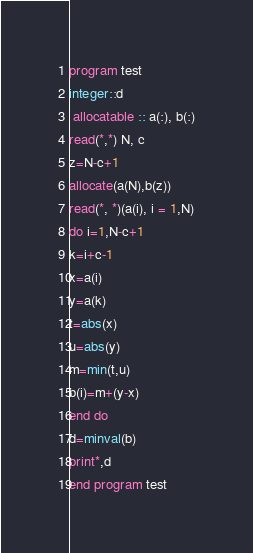Convert code to text. <code><loc_0><loc_0><loc_500><loc_500><_FORTRAN_>program test
integer::d
 allocatable :: a(:), b(:)
read(*,*) N, c
z=N-c+1
allocate(a(N),b(z))
read(*, *)(a(i), i = 1,N)
do i=1,N-c+1
k=i+c-1
x=a(i)
y=a(k)
t=abs(x)
u=abs(y)
m=min(t,u)
b(i)=m+(y-x)
end do
d=minval(b)
print*,d
end program test</code> 